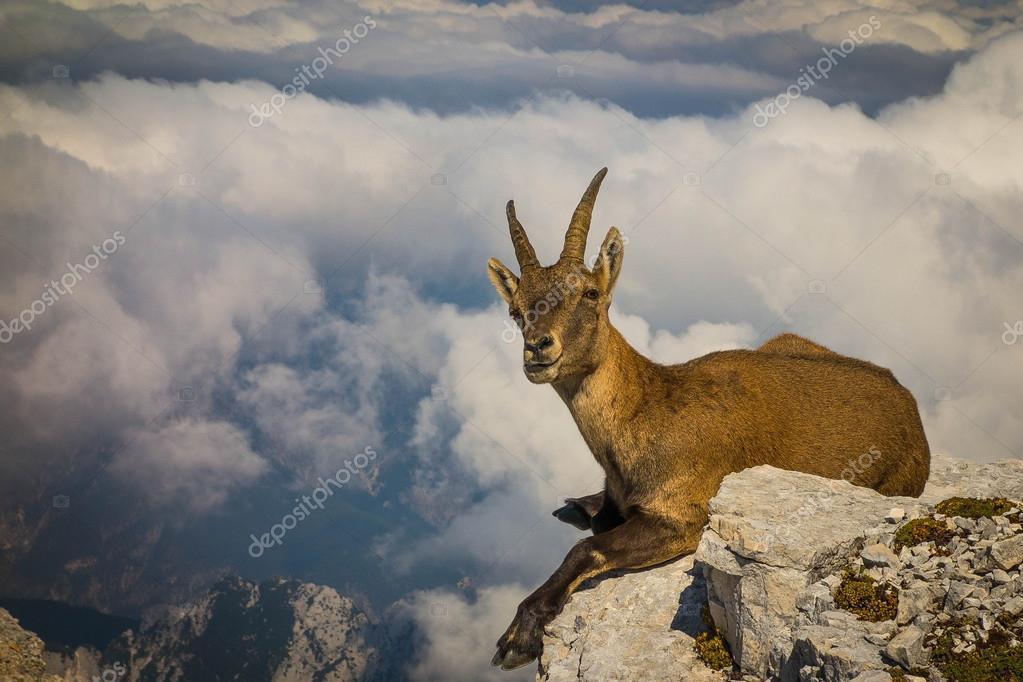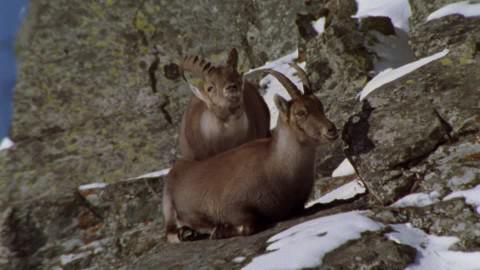The first image is the image on the left, the second image is the image on the right. Evaluate the accuracy of this statement regarding the images: "The animals in the image on the right are on a snowy rocky cliff.". Is it true? Answer yes or no. Yes. The first image is the image on the left, the second image is the image on the right. Considering the images on both sides, is "An image shows two hooved animals on a rocky mountainside with patches of white snow." valid? Answer yes or no. Yes. 